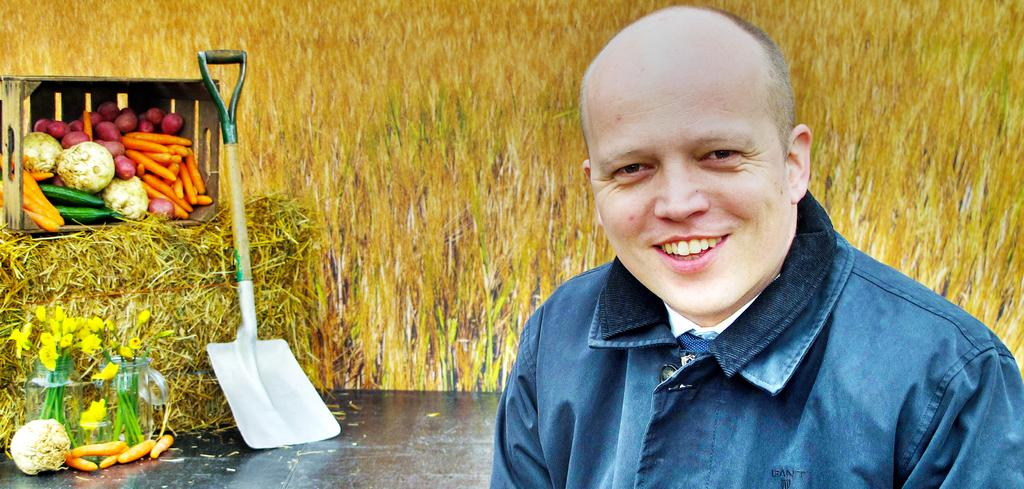Who is present in the image? There is a man in the image. What is the man's facial expression? The man is smiling. What type of surface is visible in the image? There is a floor in the image. What type of food items can be seen in the image? There are vegetables in the image. What object is present that can be used for storage? There is a box in the image. What type of decorative objects are present in the image? There are flower vases in the image. What type of object can be used for a specific task or purpose? There is a tool in the image. What type of natural material is visible in the image? There is dried grass in the image. What type of signage is visible in the background of the image? There is a banner in the background of the image. What time of day is it in the image, and is there a bat flying around? The time of day cannot be determined from the image, and there is no bat visible in the image. 